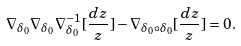<formula> <loc_0><loc_0><loc_500><loc_500>\nabla _ { \delta _ { 0 } } \nabla _ { \delta _ { 0 } } \nabla _ { \delta _ { 0 } } ^ { - 1 } [ \frac { d z } { z } ] - \nabla _ { \delta _ { 0 } \circ \delta _ { 0 } } [ \frac { d z } { z } ] = 0 .</formula> 